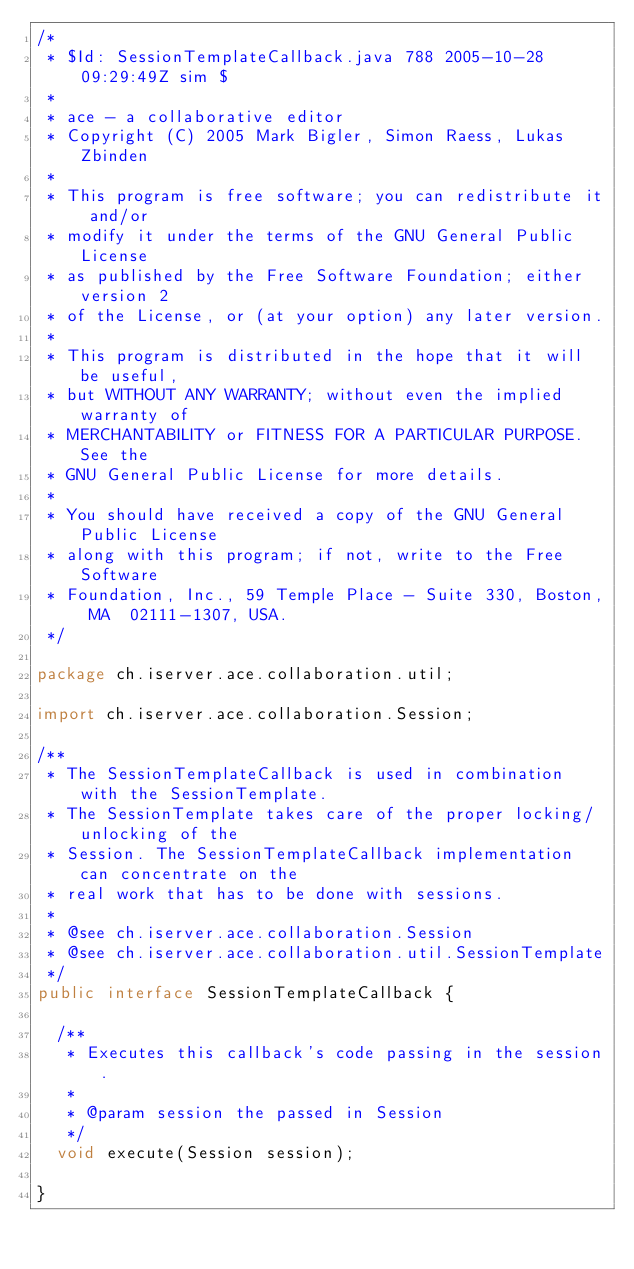Convert code to text. <code><loc_0><loc_0><loc_500><loc_500><_Java_>/*
 * $Id: SessionTemplateCallback.java 788 2005-10-28 09:29:49Z sim $
 *
 * ace - a collaborative editor
 * Copyright (C) 2005 Mark Bigler, Simon Raess, Lukas Zbinden
 *
 * This program is free software; you can redistribute it and/or
 * modify it under the terms of the GNU General Public License
 * as published by the Free Software Foundation; either version 2
 * of the License, or (at your option) any later version.
 *
 * This program is distributed in the hope that it will be useful,
 * but WITHOUT ANY WARRANTY; without even the implied warranty of
 * MERCHANTABILITY or FITNESS FOR A PARTICULAR PURPOSE.  See the
 * GNU General Public License for more details.
 *
 * You should have received a copy of the GNU General Public License
 * along with this program; if not, write to the Free Software
 * Foundation, Inc., 59 Temple Place - Suite 330, Boston, MA  02111-1307, USA.
 */

package ch.iserver.ace.collaboration.util;

import ch.iserver.ace.collaboration.Session;

/**
 * The SessionTemplateCallback is used in combination with the SessionTemplate.
 * The SessionTemplate takes care of the proper locking/unlocking of the
 * Session. The SessionTemplateCallback implementation can concentrate on the
 * real work that has to be done with sessions.
 * 
 * @see ch.iserver.ace.collaboration.Session
 * @see ch.iserver.ace.collaboration.util.SessionTemplate
 */
public interface SessionTemplateCallback {
	
	/**
	 * Executes this callback's code passing in the session.
	 * 
	 * @param session the passed in Session
	 */
	void execute(Session session);
	
}
</code> 